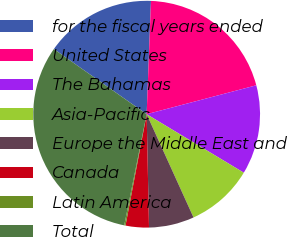<chart> <loc_0><loc_0><loc_500><loc_500><pie_chart><fcel>for the fiscal years ended<fcel>United States<fcel>The Bahamas<fcel>Asia-Pacific<fcel>Europe the Middle East and<fcel>Canada<fcel>Latin America<fcel>Total<nl><fcel>15.87%<fcel>20.29%<fcel>12.73%<fcel>9.59%<fcel>6.45%<fcel>3.32%<fcel>0.18%<fcel>31.57%<nl></chart> 